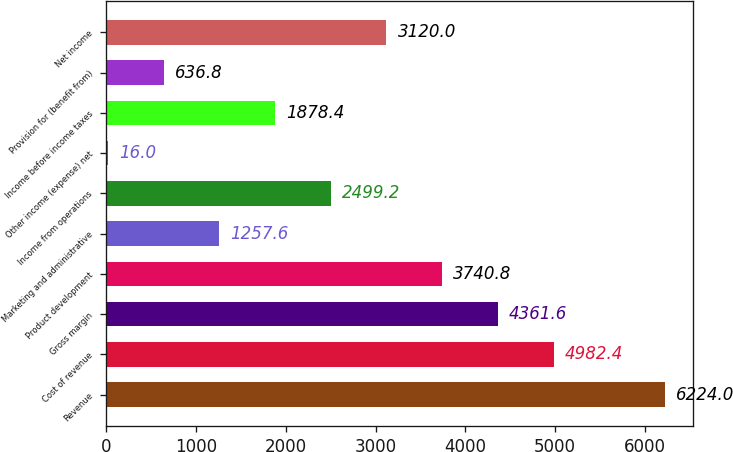Convert chart. <chart><loc_0><loc_0><loc_500><loc_500><bar_chart><fcel>Revenue<fcel>Cost of revenue<fcel>Gross margin<fcel>Product development<fcel>Marketing and administrative<fcel>Income from operations<fcel>Other income (expense) net<fcel>Income before income taxes<fcel>Provision for (benefit from)<fcel>Net income<nl><fcel>6224<fcel>4982.4<fcel>4361.6<fcel>3740.8<fcel>1257.6<fcel>2499.2<fcel>16<fcel>1878.4<fcel>636.8<fcel>3120<nl></chart> 